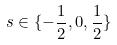Convert formula to latex. <formula><loc_0><loc_0><loc_500><loc_500>s \in \{ - \frac { 1 } { 2 } , 0 , \frac { 1 } { 2 } \}</formula> 